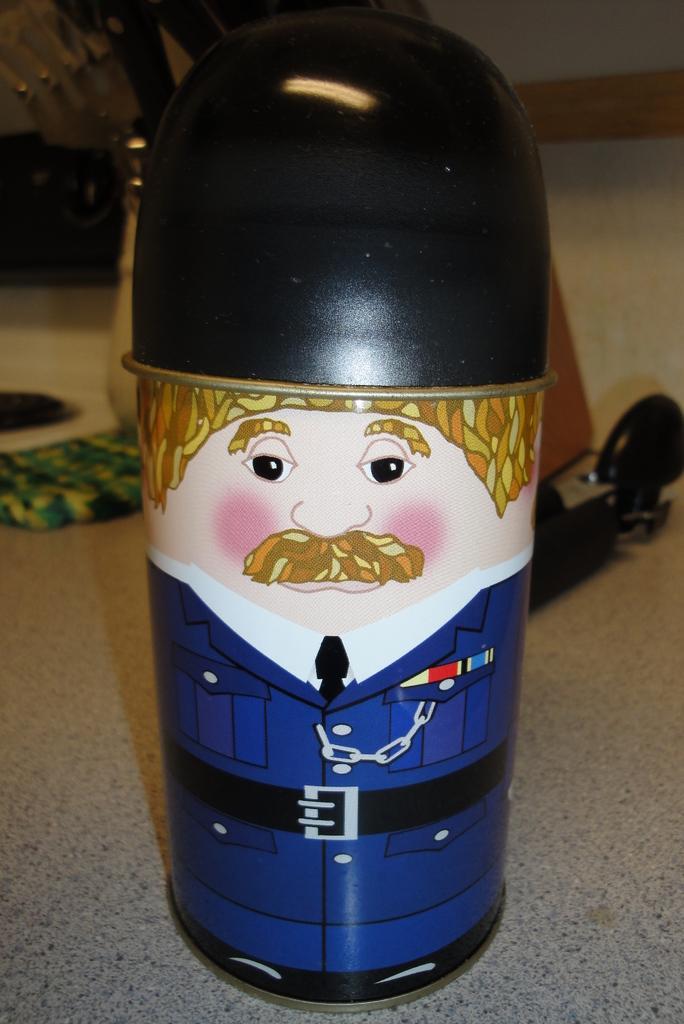Can you describe this image briefly? In this image I can see the toy person and the person is wearing blue color dress, background I can see few objects on the floor and the wall is in white color. 